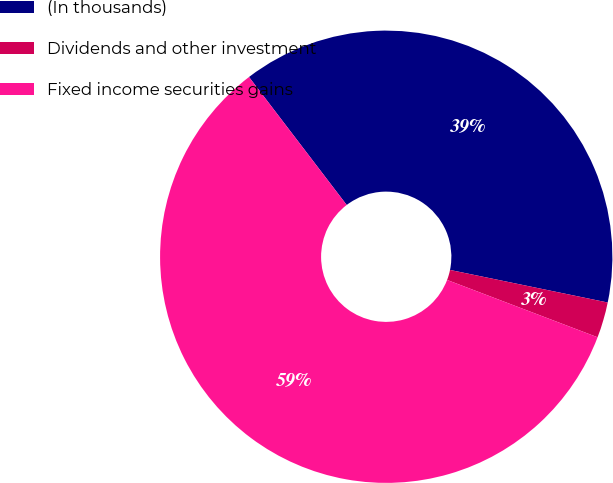<chart> <loc_0><loc_0><loc_500><loc_500><pie_chart><fcel>(In thousands)<fcel>Dividends and other investment<fcel>Fixed income securities gains<nl><fcel>38.62%<fcel>2.55%<fcel>58.83%<nl></chart> 